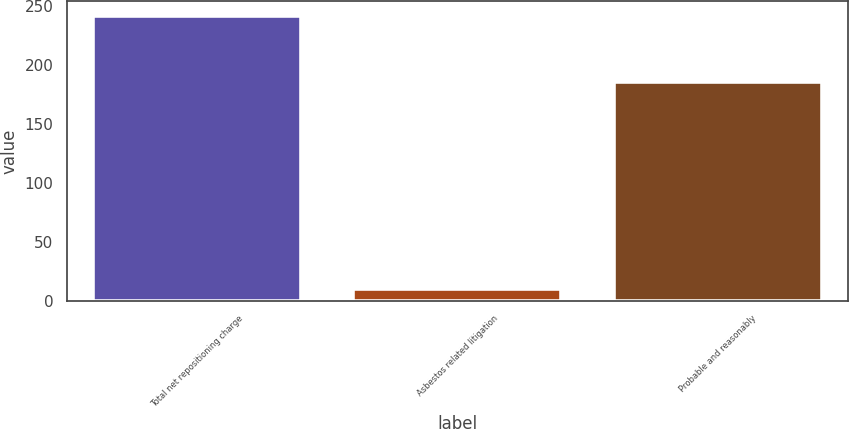Convert chart. <chart><loc_0><loc_0><loc_500><loc_500><bar_chart><fcel>Total net repositioning charge<fcel>Asbestos related litigation<fcel>Probable and reasonably<nl><fcel>242<fcel>10<fcel>186<nl></chart> 